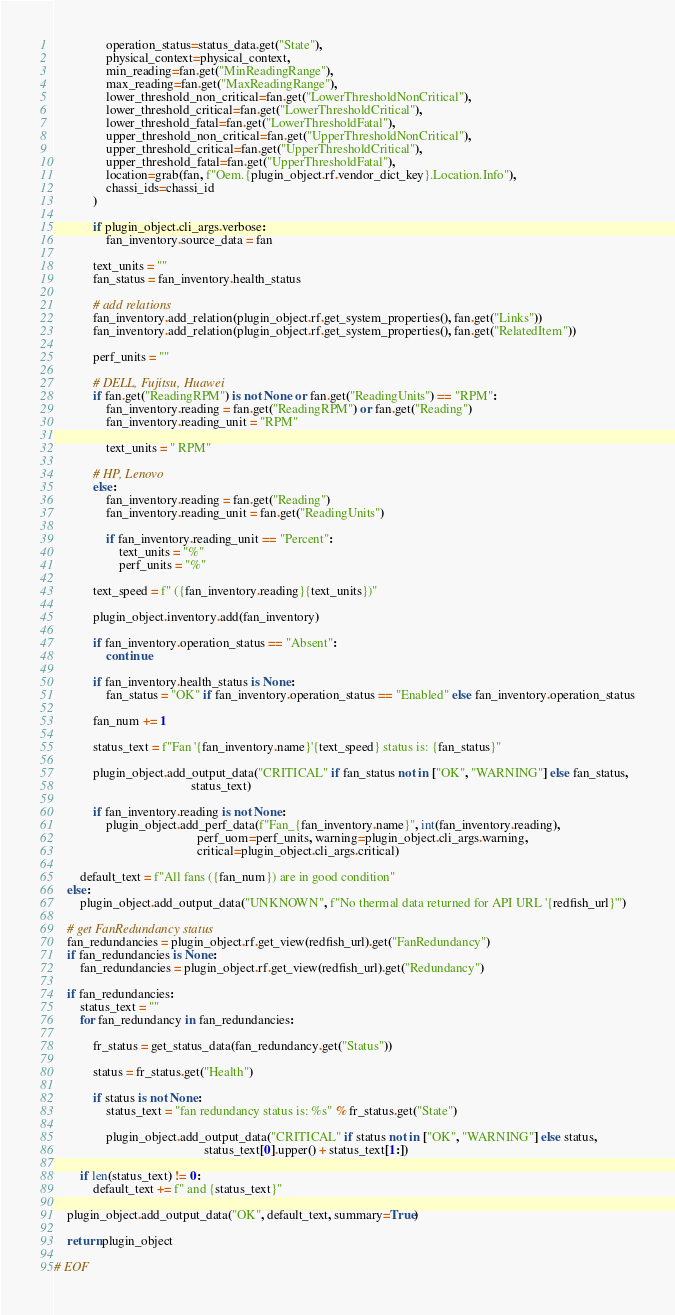Convert code to text. <code><loc_0><loc_0><loc_500><loc_500><_Python_>                operation_status=status_data.get("State"),
                physical_context=physical_context,
                min_reading=fan.get("MinReadingRange"),
                max_reading=fan.get("MaxReadingRange"),
                lower_threshold_non_critical=fan.get("LowerThresholdNonCritical"),
                lower_threshold_critical=fan.get("LowerThresholdCritical"),
                lower_threshold_fatal=fan.get("LowerThresholdFatal"),
                upper_threshold_non_critical=fan.get("UpperThresholdNonCritical"),
                upper_threshold_critical=fan.get("UpperThresholdCritical"),
                upper_threshold_fatal=fan.get("UpperThresholdFatal"),
                location=grab(fan, f"Oem.{plugin_object.rf.vendor_dict_key}.Location.Info"),
                chassi_ids=chassi_id
            )

            if plugin_object.cli_args.verbose:
                fan_inventory.source_data = fan

            text_units = ""
            fan_status = fan_inventory.health_status

            # add relations
            fan_inventory.add_relation(plugin_object.rf.get_system_properties(), fan.get("Links"))
            fan_inventory.add_relation(plugin_object.rf.get_system_properties(), fan.get("RelatedItem"))

            perf_units = ""

            # DELL, Fujitsu, Huawei
            if fan.get("ReadingRPM") is not None or fan.get("ReadingUnits") == "RPM":
                fan_inventory.reading = fan.get("ReadingRPM") or fan.get("Reading")
                fan_inventory.reading_unit = "RPM"

                text_units = " RPM"

            # HP, Lenovo
            else:
                fan_inventory.reading = fan.get("Reading")
                fan_inventory.reading_unit = fan.get("ReadingUnits")

                if fan_inventory.reading_unit == "Percent":
                    text_units = "%"
                    perf_units = "%"

            text_speed = f" ({fan_inventory.reading}{text_units})"

            plugin_object.inventory.add(fan_inventory)

            if fan_inventory.operation_status == "Absent":
                continue

            if fan_inventory.health_status is None:
                fan_status = "OK" if fan_inventory.operation_status == "Enabled" else fan_inventory.operation_status

            fan_num += 1

            status_text = f"Fan '{fan_inventory.name}'{text_speed} status is: {fan_status}"

            plugin_object.add_output_data("CRITICAL" if fan_status not in ["OK", "WARNING"] else fan_status,
                                          status_text)

            if fan_inventory.reading is not None:
                plugin_object.add_perf_data(f"Fan_{fan_inventory.name}", int(fan_inventory.reading),
                                            perf_uom=perf_units, warning=plugin_object.cli_args.warning,
                                            critical=plugin_object.cli_args.critical)

        default_text = f"All fans ({fan_num}) are in good condition"
    else:
        plugin_object.add_output_data("UNKNOWN", f"No thermal data returned for API URL '{redfish_url}'")

    # get FanRedundancy status
    fan_redundancies = plugin_object.rf.get_view(redfish_url).get("FanRedundancy")
    if fan_redundancies is None:
        fan_redundancies = plugin_object.rf.get_view(redfish_url).get("Redundancy")

    if fan_redundancies:
        status_text = ""
        for fan_redundancy in fan_redundancies:

            fr_status = get_status_data(fan_redundancy.get("Status"))

            status = fr_status.get("Health")

            if status is not None:
                status_text = "fan redundancy status is: %s" % fr_status.get("State")

                plugin_object.add_output_data("CRITICAL" if status not in ["OK", "WARNING"] else status,
                                              status_text[0].upper() + status_text[1:])

        if len(status_text) != 0:
            default_text += f" and {status_text}"

    plugin_object.add_output_data("OK", default_text, summary=True)

    return plugin_object

# EOF
</code> 